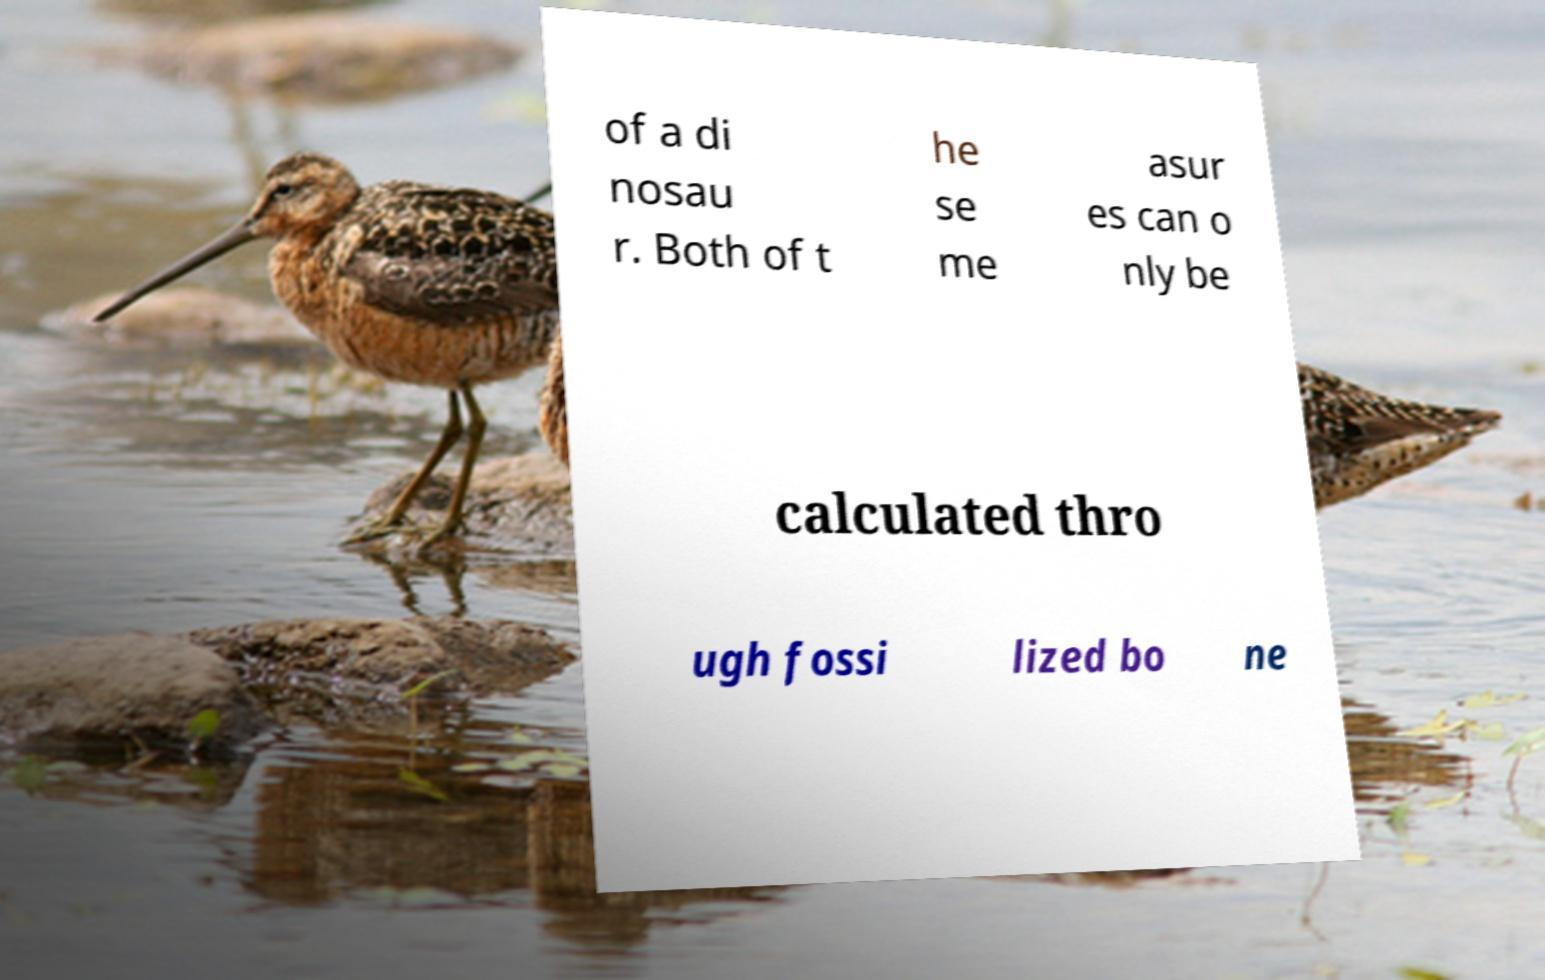Please read and relay the text visible in this image. What does it say? of a di nosau r. Both of t he se me asur es can o nly be calculated thro ugh fossi lized bo ne 